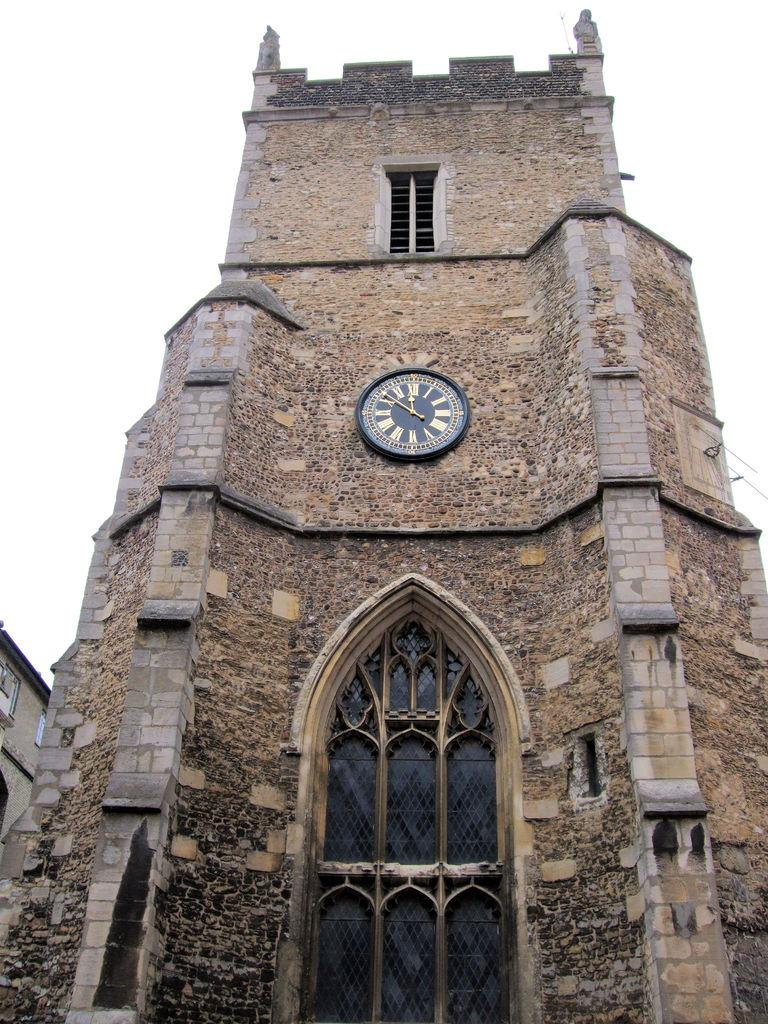<image>
Create a compact narrative representing the image presented. The watch on the tower is set at 10. 